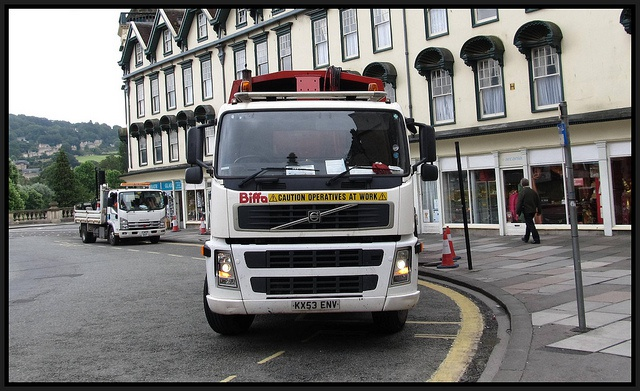Describe the objects in this image and their specific colors. I can see truck in black, gray, darkgray, and lightgray tones, truck in black, darkgray, gray, and lightgray tones, people in black, gray, maroon, and darkgray tones, and people in black, maroon, purple, and brown tones in this image. 